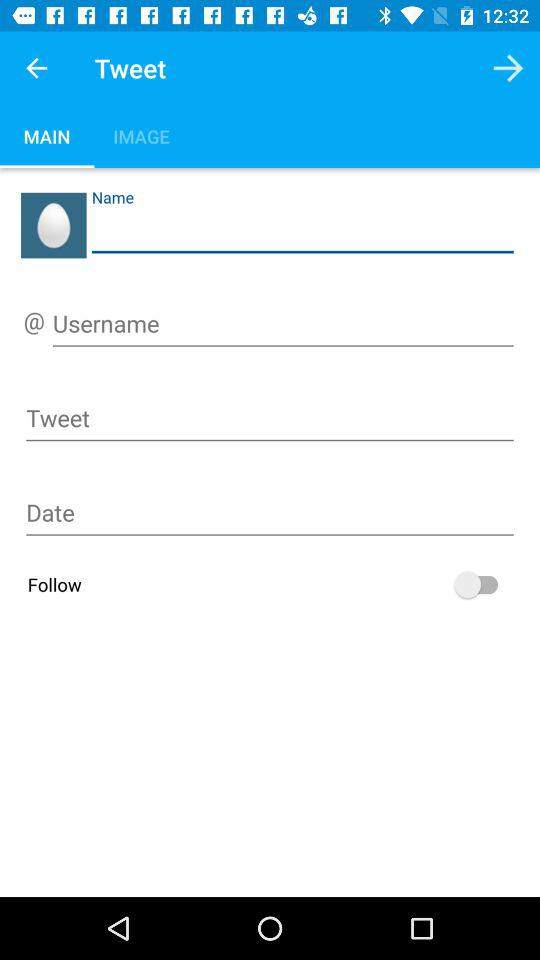What is the username?
When the provided information is insufficient, respond with <no answer>. <no answer> 